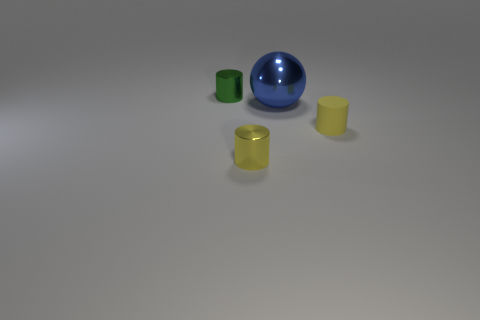Add 2 big purple spheres. How many objects exist? 6 Subtract all green cylinders. Subtract all blue balls. How many cylinders are left? 2 Subtract all balls. How many objects are left? 3 Subtract 0 brown cylinders. How many objects are left? 4 Subtract all large blue shiny spheres. Subtract all small metallic objects. How many objects are left? 1 Add 2 large blue shiny objects. How many large blue shiny objects are left? 3 Add 1 tiny blue metal balls. How many tiny blue metal balls exist? 1 